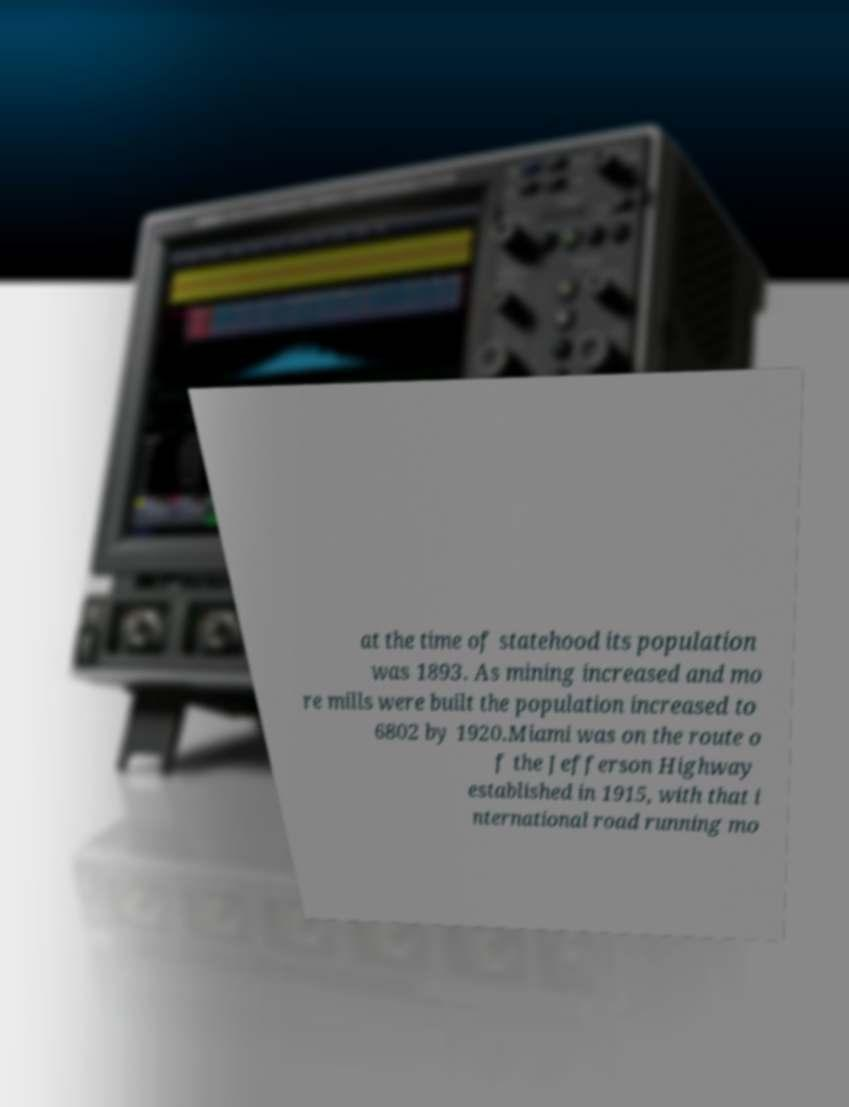Please identify and transcribe the text found in this image. at the time of statehood its population was 1893. As mining increased and mo re mills were built the population increased to 6802 by 1920.Miami was on the route o f the Jefferson Highway established in 1915, with that i nternational road running mo 